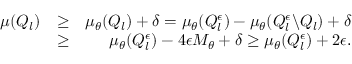<formula> <loc_0><loc_0><loc_500><loc_500>\begin{array} { r l r } { \mu ( Q _ { l } ) } & { \geq } & { \mu _ { \theta } ( Q _ { l } ) + \delta = \mu _ { \theta } ( Q _ { l } ^ { \epsilon } ) - \mu _ { \theta } ( Q _ { l } ^ { \epsilon } \ Q _ { l } ) + \delta } \\ & { \geq } & { \mu _ { \theta } ( Q _ { l } ^ { \epsilon } ) - 4 \epsilon M _ { \theta } + \delta \geq \mu _ { \theta } ( Q _ { l } ^ { \epsilon } ) + 2 \epsilon . } \end{array}</formula> 